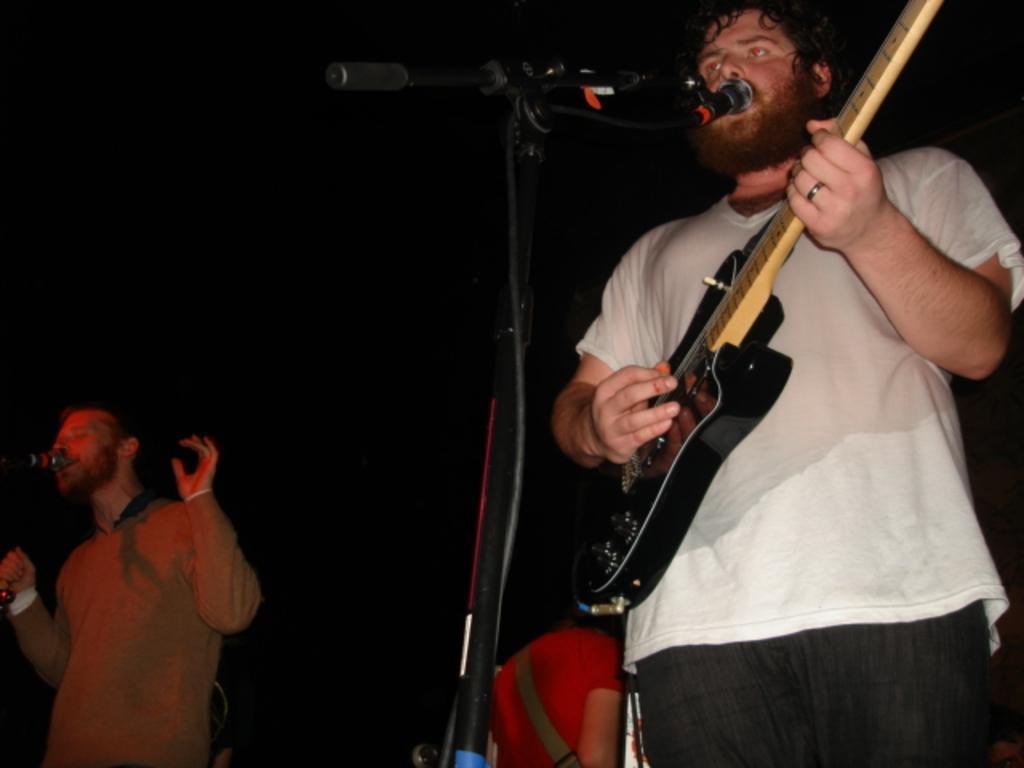Can you describe this image briefly? In this image i can see there are two men standing in front of a microphone. The person in the right side is playing a guitar. 